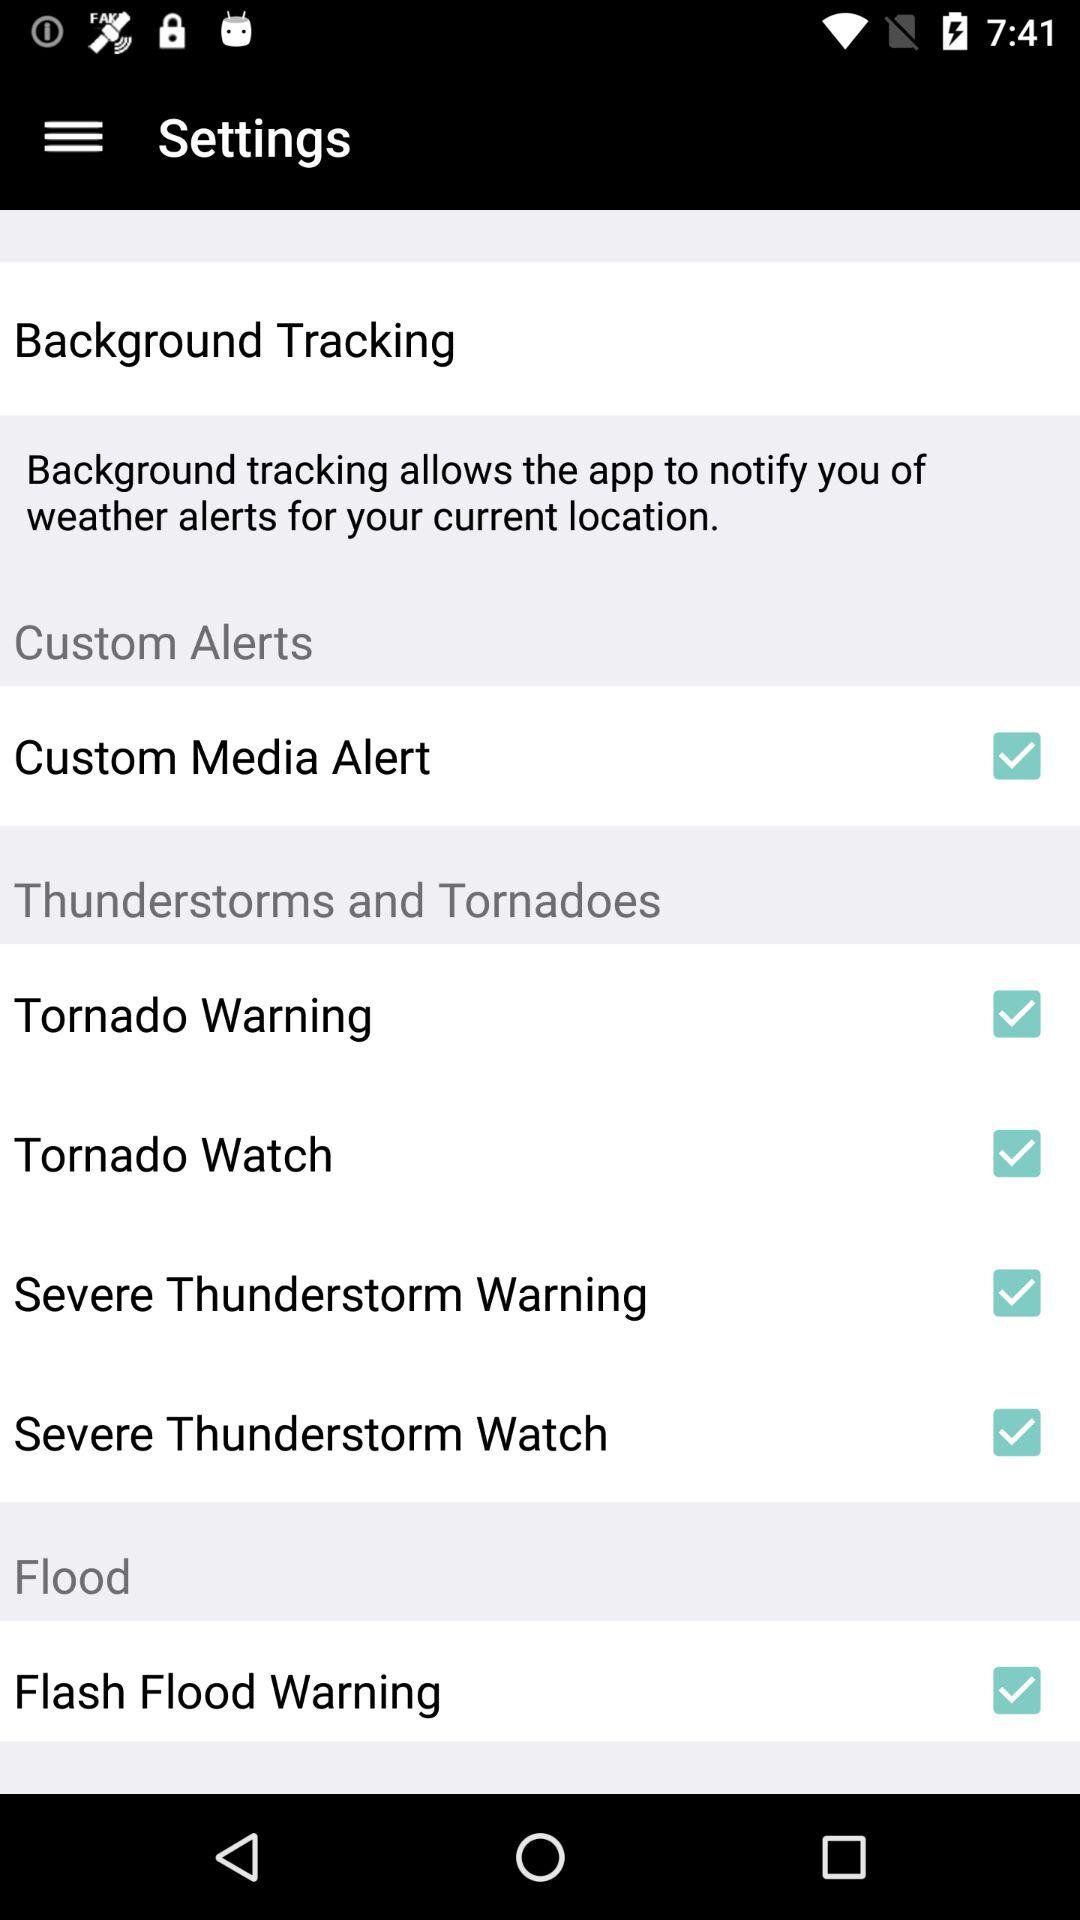What is the status of "Background Tracking"?
When the provided information is insufficient, respond with <no answer>. <no answer> 